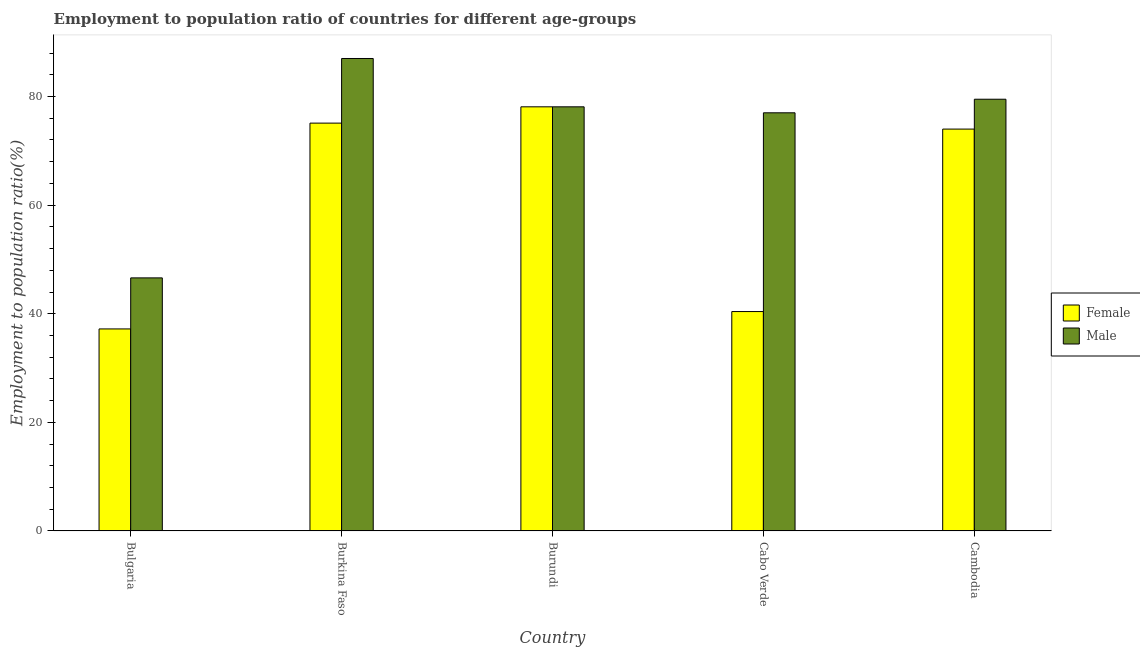How many groups of bars are there?
Give a very brief answer. 5. Are the number of bars on each tick of the X-axis equal?
Your answer should be compact. Yes. How many bars are there on the 4th tick from the right?
Give a very brief answer. 2. What is the label of the 2nd group of bars from the left?
Provide a short and direct response. Burkina Faso. In how many cases, is the number of bars for a given country not equal to the number of legend labels?
Your response must be concise. 0. What is the employment to population ratio(female) in Cabo Verde?
Your answer should be compact. 40.4. Across all countries, what is the maximum employment to population ratio(female)?
Keep it short and to the point. 78.1. Across all countries, what is the minimum employment to population ratio(male)?
Offer a very short reply. 46.6. In which country was the employment to population ratio(female) maximum?
Your response must be concise. Burundi. What is the total employment to population ratio(male) in the graph?
Provide a succinct answer. 368.2. What is the difference between the employment to population ratio(male) in Cambodia and the employment to population ratio(female) in Cabo Verde?
Make the answer very short. 39.1. What is the average employment to population ratio(female) per country?
Your answer should be compact. 60.96. What is the difference between the employment to population ratio(female) and employment to population ratio(male) in Burkina Faso?
Your response must be concise. -11.9. What is the ratio of the employment to population ratio(male) in Burkina Faso to that in Cambodia?
Ensure brevity in your answer.  1.09. What is the difference between the highest and the lowest employment to population ratio(male)?
Ensure brevity in your answer.  40.4. What does the 1st bar from the right in Bulgaria represents?
Provide a succinct answer. Male. How many bars are there?
Your answer should be compact. 10. Are all the bars in the graph horizontal?
Provide a short and direct response. No. What is the difference between two consecutive major ticks on the Y-axis?
Offer a terse response. 20. Does the graph contain any zero values?
Your answer should be compact. No. Does the graph contain grids?
Ensure brevity in your answer.  No. How many legend labels are there?
Your answer should be compact. 2. How are the legend labels stacked?
Ensure brevity in your answer.  Vertical. What is the title of the graph?
Ensure brevity in your answer.  Employment to population ratio of countries for different age-groups. Does "Techinal cooperation" appear as one of the legend labels in the graph?
Offer a very short reply. No. What is the label or title of the X-axis?
Your response must be concise. Country. What is the label or title of the Y-axis?
Make the answer very short. Employment to population ratio(%). What is the Employment to population ratio(%) in Female in Bulgaria?
Provide a succinct answer. 37.2. What is the Employment to population ratio(%) in Male in Bulgaria?
Make the answer very short. 46.6. What is the Employment to population ratio(%) of Female in Burkina Faso?
Ensure brevity in your answer.  75.1. What is the Employment to population ratio(%) in Male in Burkina Faso?
Your response must be concise. 87. What is the Employment to population ratio(%) of Female in Burundi?
Your answer should be compact. 78.1. What is the Employment to population ratio(%) of Male in Burundi?
Ensure brevity in your answer.  78.1. What is the Employment to population ratio(%) of Female in Cabo Verde?
Give a very brief answer. 40.4. What is the Employment to population ratio(%) in Female in Cambodia?
Give a very brief answer. 74. What is the Employment to population ratio(%) of Male in Cambodia?
Offer a very short reply. 79.5. Across all countries, what is the maximum Employment to population ratio(%) in Female?
Provide a succinct answer. 78.1. Across all countries, what is the maximum Employment to population ratio(%) of Male?
Offer a terse response. 87. Across all countries, what is the minimum Employment to population ratio(%) of Female?
Your answer should be very brief. 37.2. Across all countries, what is the minimum Employment to population ratio(%) of Male?
Your response must be concise. 46.6. What is the total Employment to population ratio(%) of Female in the graph?
Keep it short and to the point. 304.8. What is the total Employment to population ratio(%) of Male in the graph?
Keep it short and to the point. 368.2. What is the difference between the Employment to population ratio(%) of Female in Bulgaria and that in Burkina Faso?
Your answer should be very brief. -37.9. What is the difference between the Employment to population ratio(%) in Male in Bulgaria and that in Burkina Faso?
Offer a terse response. -40.4. What is the difference between the Employment to population ratio(%) of Female in Bulgaria and that in Burundi?
Your response must be concise. -40.9. What is the difference between the Employment to population ratio(%) in Male in Bulgaria and that in Burundi?
Your answer should be very brief. -31.5. What is the difference between the Employment to population ratio(%) of Female in Bulgaria and that in Cabo Verde?
Keep it short and to the point. -3.2. What is the difference between the Employment to population ratio(%) of Male in Bulgaria and that in Cabo Verde?
Give a very brief answer. -30.4. What is the difference between the Employment to population ratio(%) in Female in Bulgaria and that in Cambodia?
Give a very brief answer. -36.8. What is the difference between the Employment to population ratio(%) in Male in Bulgaria and that in Cambodia?
Give a very brief answer. -32.9. What is the difference between the Employment to population ratio(%) in Female in Burkina Faso and that in Burundi?
Your response must be concise. -3. What is the difference between the Employment to population ratio(%) of Female in Burkina Faso and that in Cabo Verde?
Your answer should be compact. 34.7. What is the difference between the Employment to population ratio(%) in Female in Burkina Faso and that in Cambodia?
Your answer should be compact. 1.1. What is the difference between the Employment to population ratio(%) of Male in Burkina Faso and that in Cambodia?
Your answer should be compact. 7.5. What is the difference between the Employment to population ratio(%) in Female in Burundi and that in Cabo Verde?
Offer a terse response. 37.7. What is the difference between the Employment to population ratio(%) of Male in Burundi and that in Cabo Verde?
Keep it short and to the point. 1.1. What is the difference between the Employment to population ratio(%) of Male in Burundi and that in Cambodia?
Provide a short and direct response. -1.4. What is the difference between the Employment to population ratio(%) in Female in Cabo Verde and that in Cambodia?
Keep it short and to the point. -33.6. What is the difference between the Employment to population ratio(%) of Male in Cabo Verde and that in Cambodia?
Your response must be concise. -2.5. What is the difference between the Employment to population ratio(%) of Female in Bulgaria and the Employment to population ratio(%) of Male in Burkina Faso?
Give a very brief answer. -49.8. What is the difference between the Employment to population ratio(%) in Female in Bulgaria and the Employment to population ratio(%) in Male in Burundi?
Offer a very short reply. -40.9. What is the difference between the Employment to population ratio(%) in Female in Bulgaria and the Employment to population ratio(%) in Male in Cabo Verde?
Provide a short and direct response. -39.8. What is the difference between the Employment to population ratio(%) of Female in Bulgaria and the Employment to population ratio(%) of Male in Cambodia?
Offer a very short reply. -42.3. What is the difference between the Employment to population ratio(%) in Female in Burkina Faso and the Employment to population ratio(%) in Male in Cambodia?
Ensure brevity in your answer.  -4.4. What is the difference between the Employment to population ratio(%) in Female in Burundi and the Employment to population ratio(%) in Male in Cabo Verde?
Make the answer very short. 1.1. What is the difference between the Employment to population ratio(%) of Female in Cabo Verde and the Employment to population ratio(%) of Male in Cambodia?
Keep it short and to the point. -39.1. What is the average Employment to population ratio(%) of Female per country?
Keep it short and to the point. 60.96. What is the average Employment to population ratio(%) in Male per country?
Ensure brevity in your answer.  73.64. What is the difference between the Employment to population ratio(%) in Female and Employment to population ratio(%) in Male in Cabo Verde?
Ensure brevity in your answer.  -36.6. What is the difference between the Employment to population ratio(%) of Female and Employment to population ratio(%) of Male in Cambodia?
Your response must be concise. -5.5. What is the ratio of the Employment to population ratio(%) in Female in Bulgaria to that in Burkina Faso?
Your answer should be very brief. 0.5. What is the ratio of the Employment to population ratio(%) in Male in Bulgaria to that in Burkina Faso?
Provide a succinct answer. 0.54. What is the ratio of the Employment to population ratio(%) in Female in Bulgaria to that in Burundi?
Your response must be concise. 0.48. What is the ratio of the Employment to population ratio(%) in Male in Bulgaria to that in Burundi?
Offer a very short reply. 0.6. What is the ratio of the Employment to population ratio(%) of Female in Bulgaria to that in Cabo Verde?
Your response must be concise. 0.92. What is the ratio of the Employment to population ratio(%) in Male in Bulgaria to that in Cabo Verde?
Ensure brevity in your answer.  0.61. What is the ratio of the Employment to population ratio(%) of Female in Bulgaria to that in Cambodia?
Your answer should be very brief. 0.5. What is the ratio of the Employment to population ratio(%) in Male in Bulgaria to that in Cambodia?
Provide a short and direct response. 0.59. What is the ratio of the Employment to population ratio(%) in Female in Burkina Faso to that in Burundi?
Make the answer very short. 0.96. What is the ratio of the Employment to population ratio(%) of Male in Burkina Faso to that in Burundi?
Provide a succinct answer. 1.11. What is the ratio of the Employment to population ratio(%) of Female in Burkina Faso to that in Cabo Verde?
Your response must be concise. 1.86. What is the ratio of the Employment to population ratio(%) in Male in Burkina Faso to that in Cabo Verde?
Your answer should be compact. 1.13. What is the ratio of the Employment to population ratio(%) of Female in Burkina Faso to that in Cambodia?
Give a very brief answer. 1.01. What is the ratio of the Employment to population ratio(%) in Male in Burkina Faso to that in Cambodia?
Make the answer very short. 1.09. What is the ratio of the Employment to population ratio(%) in Female in Burundi to that in Cabo Verde?
Your answer should be compact. 1.93. What is the ratio of the Employment to population ratio(%) of Male in Burundi to that in Cabo Verde?
Your answer should be very brief. 1.01. What is the ratio of the Employment to population ratio(%) in Female in Burundi to that in Cambodia?
Your response must be concise. 1.06. What is the ratio of the Employment to population ratio(%) of Male in Burundi to that in Cambodia?
Offer a terse response. 0.98. What is the ratio of the Employment to population ratio(%) in Female in Cabo Verde to that in Cambodia?
Provide a short and direct response. 0.55. What is the ratio of the Employment to population ratio(%) in Male in Cabo Verde to that in Cambodia?
Offer a very short reply. 0.97. What is the difference between the highest and the lowest Employment to population ratio(%) of Female?
Your answer should be compact. 40.9. What is the difference between the highest and the lowest Employment to population ratio(%) in Male?
Offer a terse response. 40.4. 